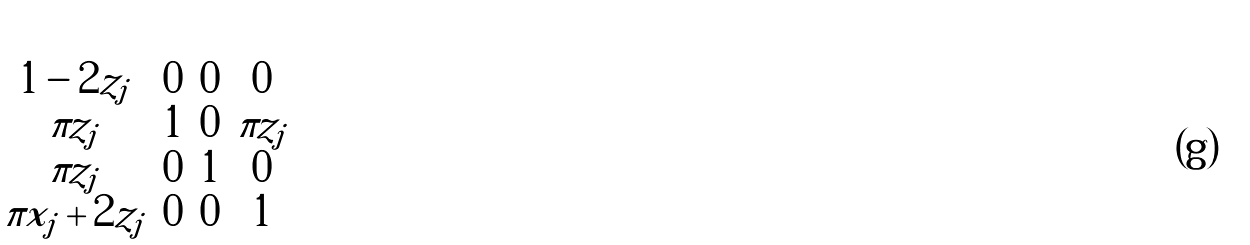<formula> <loc_0><loc_0><loc_500><loc_500>\begin{pmatrix} 1 - 2 z _ { j } & 0 & 0 & 0 \\ \pi z _ { j } & 1 & 0 & \pi z _ { j } \\ \pi z _ { j } & 0 & 1 & 0 \\ \pi x _ { j } + 2 z _ { j } & 0 & 0 & 1 \end{pmatrix}</formula> 